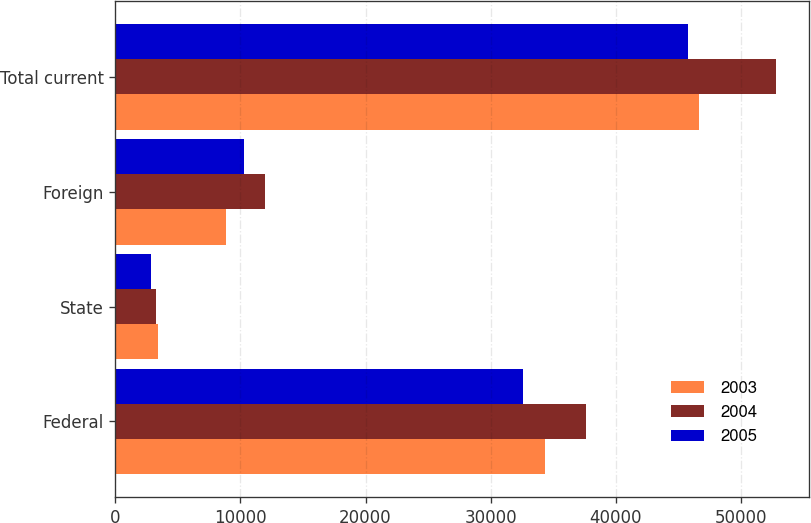Convert chart. <chart><loc_0><loc_0><loc_500><loc_500><stacked_bar_chart><ecel><fcel>Federal<fcel>State<fcel>Foreign<fcel>Total current<nl><fcel>2003<fcel>34320<fcel>3436<fcel>8858<fcel>46614<nl><fcel>2004<fcel>37580<fcel>3268<fcel>11974<fcel>52822<nl><fcel>2005<fcel>32602<fcel>2835<fcel>10321<fcel>45758<nl></chart> 